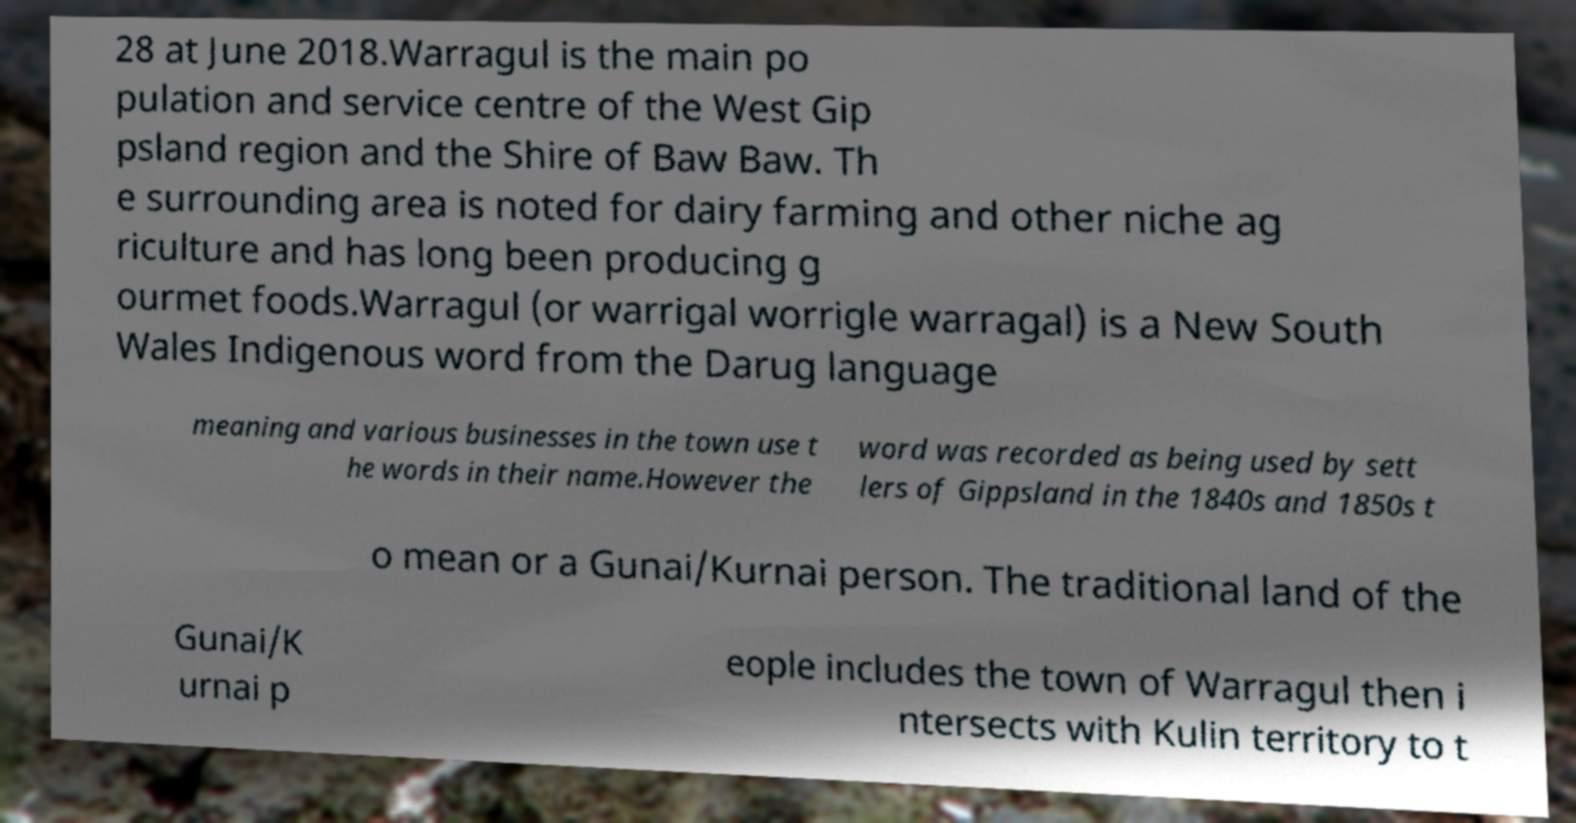Could you assist in decoding the text presented in this image and type it out clearly? 28 at June 2018.Warragul is the main po pulation and service centre of the West Gip psland region and the Shire of Baw Baw. Th e surrounding area is noted for dairy farming and other niche ag riculture and has long been producing g ourmet foods.Warragul (or warrigal worrigle warragal) is a New South Wales Indigenous word from the Darug language meaning and various businesses in the town use t he words in their name.However the word was recorded as being used by sett lers of Gippsland in the 1840s and 1850s t o mean or a Gunai/Kurnai person. The traditional land of the Gunai/K urnai p eople includes the town of Warragul then i ntersects with Kulin territory to t 